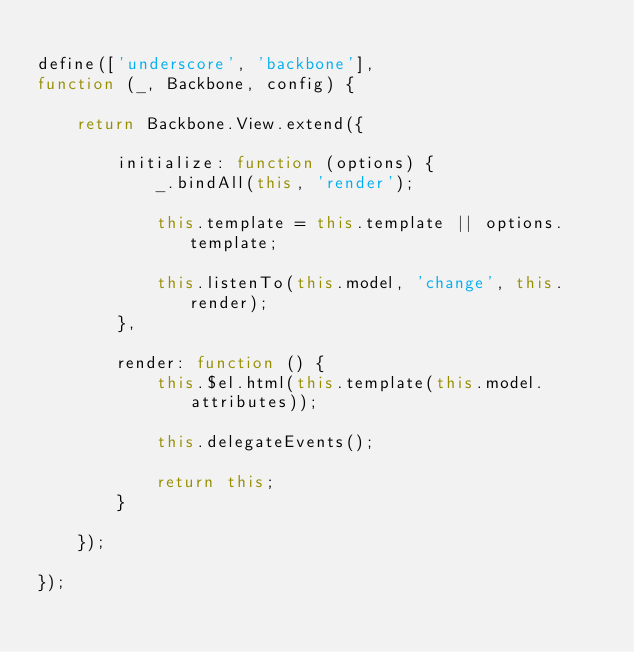<code> <loc_0><loc_0><loc_500><loc_500><_JavaScript_>
define(['underscore', 'backbone'],
function (_, Backbone, config) {

    return Backbone.View.extend({

        initialize: function (options) {
            _.bindAll(this, 'render');

            this.template = this.template || options.template;

            this.listenTo(this.model, 'change', this.render);
        },

        render: function () {
            this.$el.html(this.template(this.model.attributes));

            this.delegateEvents();

            return this;
        }

    });

});</code> 